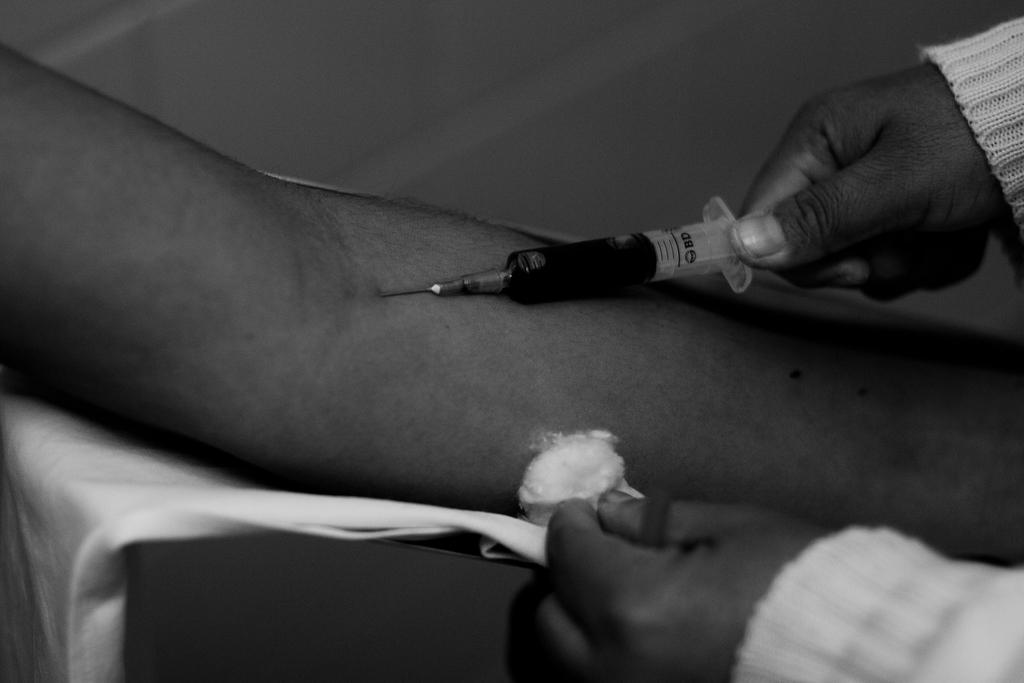What is the color scheme of the image? The image is black and white. What is happening in the image? There is a person administering an injection, and another person is receiving the injection. How many people are present in the image? There are two people in the image. What type of ear jewelry is the person receiving the injection wearing? There is no ear jewelry visible in the image, as the image is black and white and focuses on the injection scene. 